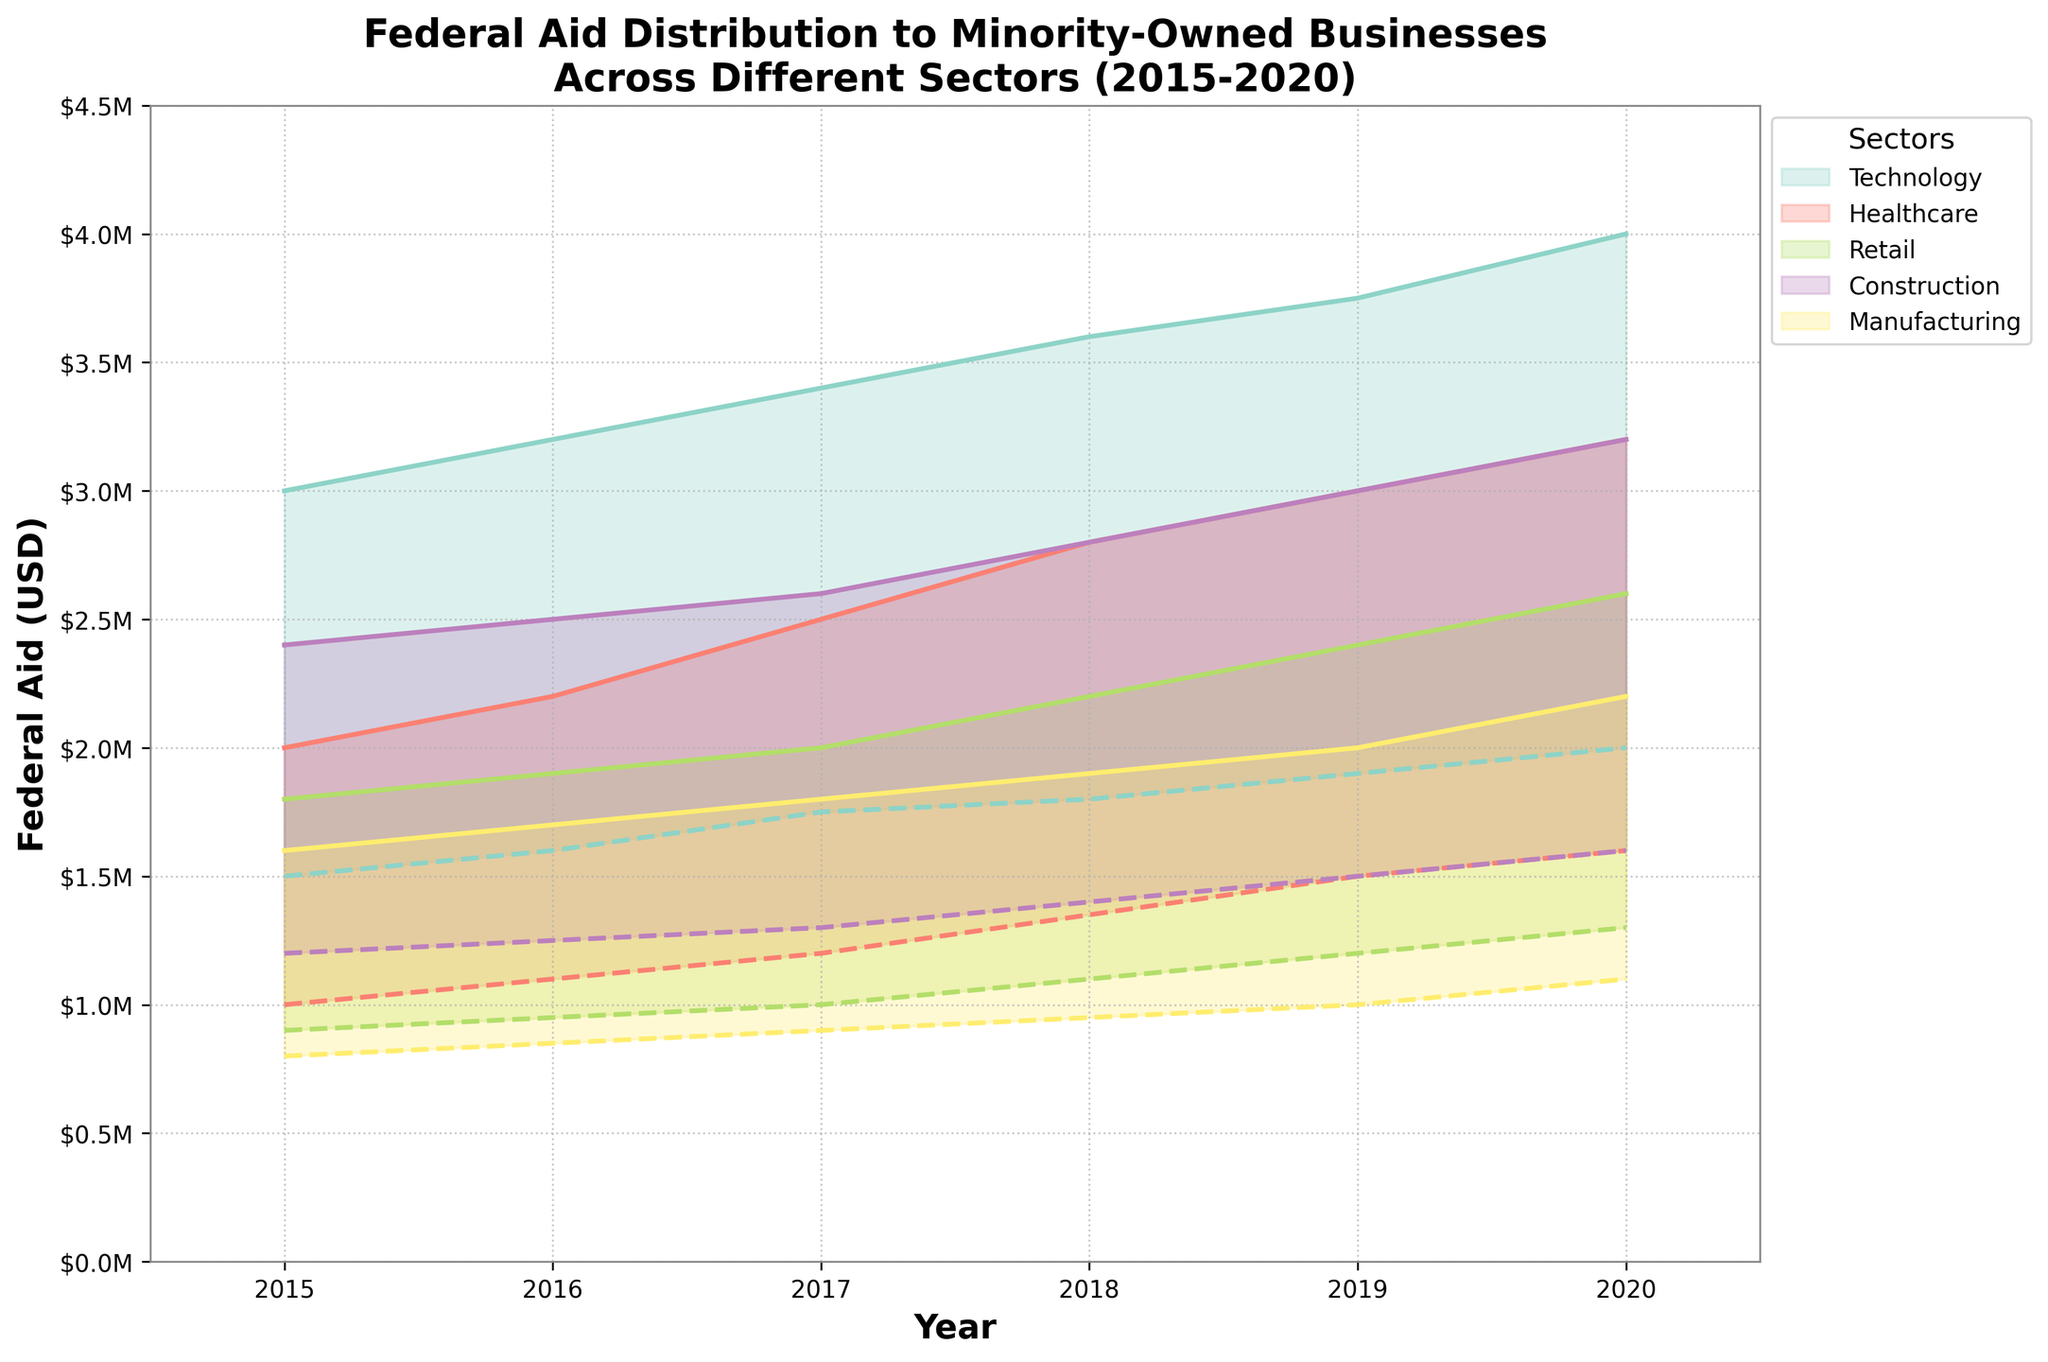What are the years covered in the figure? The x-axis displays the range of years from 2015 to 2020.
Answer: 2015-2020 Which sector received the highest maximum federal aid in 2020? In 2020, the Technology sector's maximum federal aid reached 4 million USD, which is higher than any other sector.
Answer: Technology How does the minimum aid in Healthcare compare between 2015 and 2020? In 2015, the minimum aid for Healthcare was 1 million USD, and in 2020, it was 1.6 million USD. Therefore, the minimum aid increased by 0.6 million USD over the period.
Answer: Increased by 0.6 million USD Which sector shows the smallest range between the maximum and minimum aid in 2015? In 2015, among all sectors, Manufacturing shows the smallest range between maximum aid (1.6 million USD) and minimum aid (0.8 million USD), which is a range of 0.8 million USD.
Answer: Manufacturing What is the general trend in the maximum aid received by the Technology sector over the years 2015 to 2020? Observing the Technology sector from 2015 to 2020, the maximum federal aid shows an upward trend, increasing from 3 million USD in 2015 to 4 million USD in 2020.
Answer: Upward trend How does the range of federal aid vary for Manufacturing between 2015 and 2020? The range of aid for Manufacturing in 2015 was 0.8 million USD (1.6 million USD - 0.8 million USD) and widened to 1.1 million USD (2.2 million USD - 1.1 million USD) by 2020.
Answer: Widened Which sector had a steady increase in both minimum and maximum aid amounts from 2015 to 2020? Both the minimum and maximum aid amounts for the Retail sector increased steadily each year from 2015 to 2020.
Answer: Retail Compare the federal aid range for Construction in 2016 and 2020. In 2016, the Construction aid range was 1.25 million USD (2.5 million USD - 1.25 million USD). By 2020, the range expanded to 1.6 million USD (3.2 million USD - 1.6 million USD).
Answer: Expanded In which year did the minimum aid for Technology first exceed 1.9 million USD? Observing the Technology minimum aid over the years, it first exceeded 1.9 million USD in 2019 when it reached 1.95 million USD.
Answer: 2019 